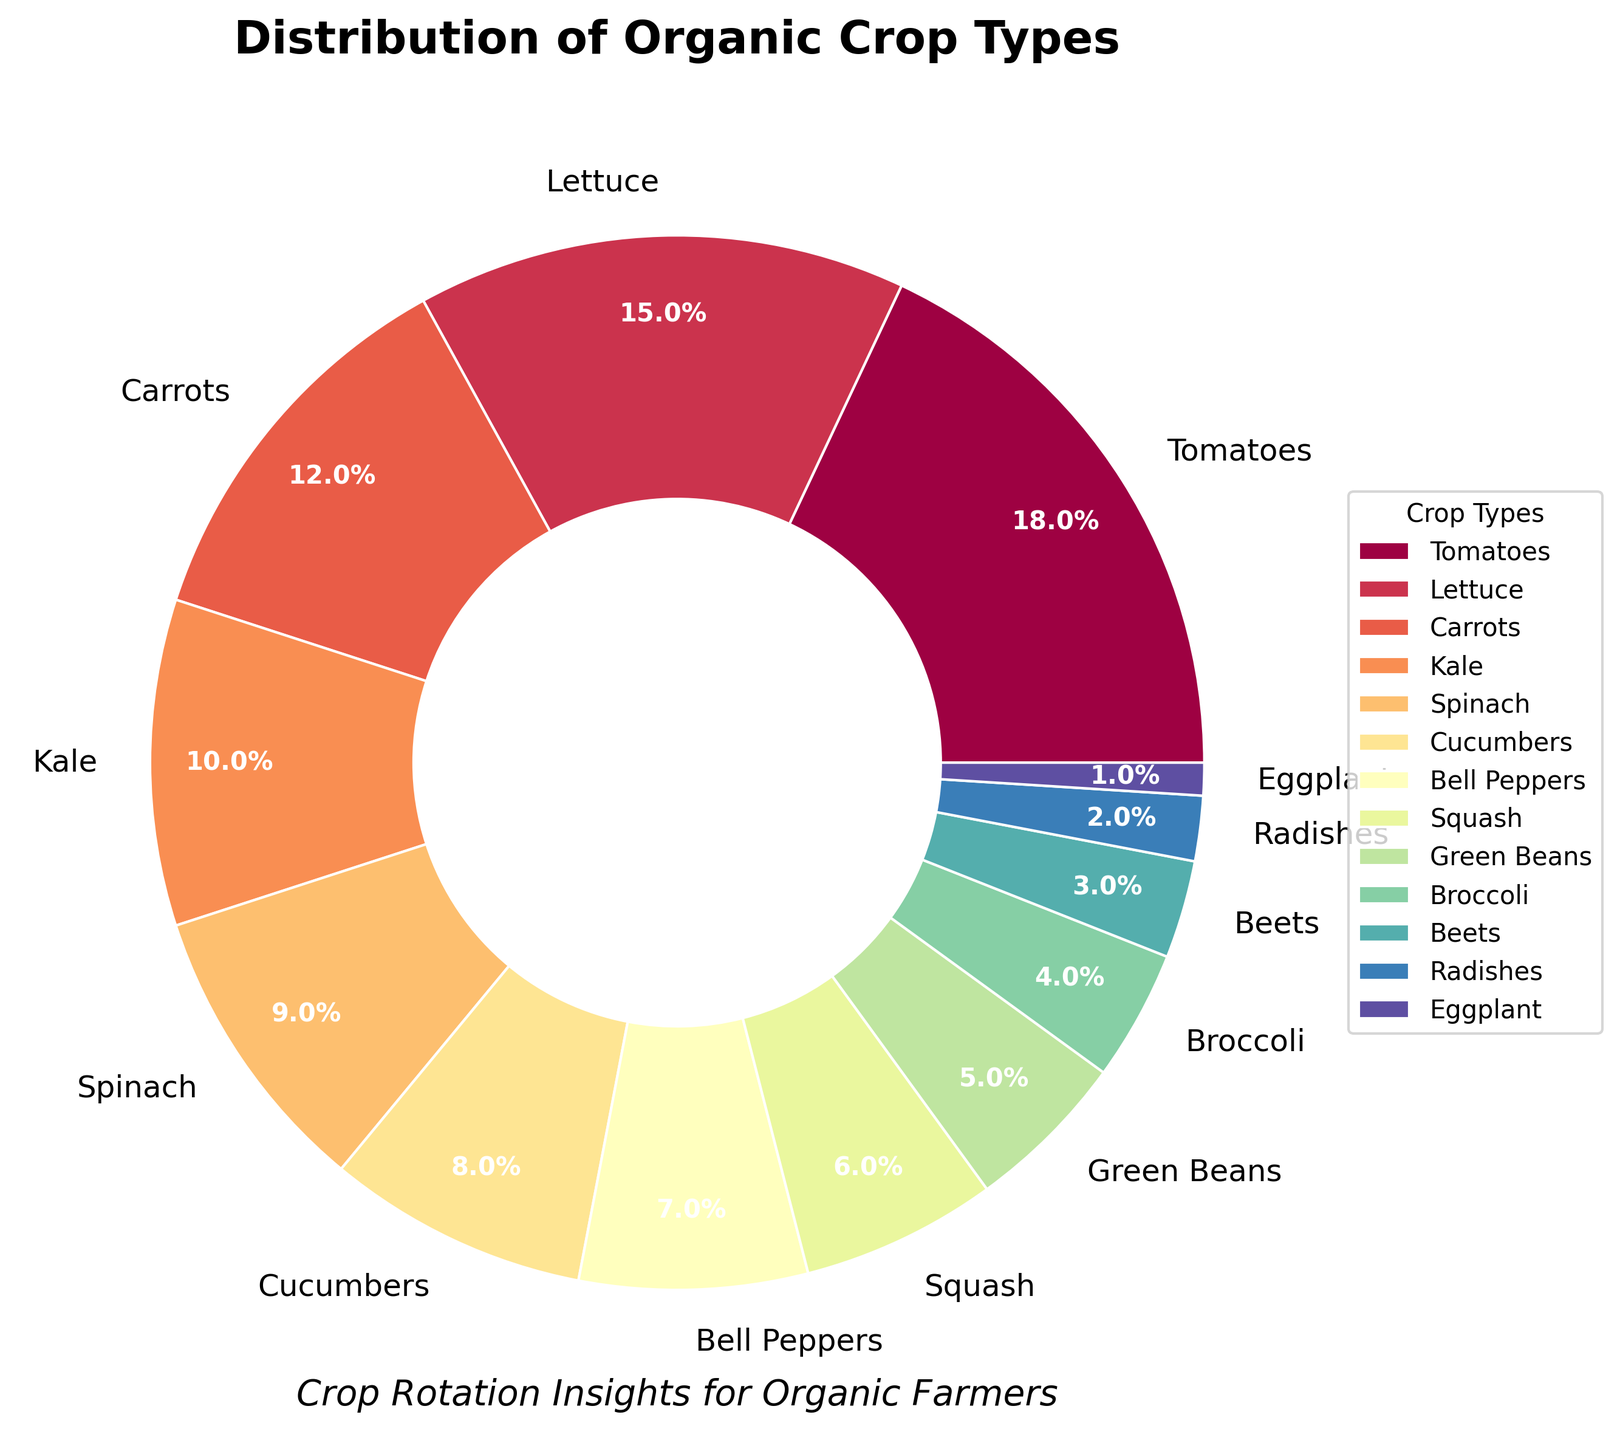What is the most grown crop according to the pie chart? The segment with the largest percentage represents the most grown crop. Tomatoes have the largest segment at 18%.
Answer: Tomatoes Which crop has the smallest percentage of growth? The segment with the smallest percentage represents the least grown crop. Eggplant has the smallest segment at 1%.
Answer: Eggplant What is the combined percentage of Lettuce, Carrots, and Kale grown in the region? Add the percentages of Lettuce, Carrots, and Kale. Lettuce (15%) + Carrots (12%) + Kale (10%) = 37%.
Answer: 37% How does the percentage of Spinach compare to that of Cucumbers? Find the percentages of both crops and compare them. Spinach is 9% and Cucumbers are 8%. Spinach has a 1% higher percentage than Cucumbers.
Answer: Spinach has a higher percentage by 1% List the crops that have a percentage of 5% or less. Identify the crops from the chart with percentages less than or equal to 5%. Green Beans (5%), Broccoli (4%), Beets (3%), Radishes (2%), and Eggplant (1%).
Answer: Green Beans, Broccoli, Beets, Radishes, and Eggplant What is the percentage difference between the most and least grown crops? Subtract the percentage of the least grown crop from the most grown crop. Tomatoes (18%) - Eggplant (1%) = 17%.
Answer: 17% What is the cumulative percentage of Squash and Beets grown? Add the percentages of Squash and Beets. Squash (6%) + Beets (3%) = 9%.
Answer: 9% If you combine the percentages of Bell Peppers and Cucumbers, how does it compare to Lettuce? Find the total percentage of Bell Peppers and Cucumbers, and compare with Lettuce. Bell Peppers (7%) + Cucumbers (8%) = 15%, which is the same as Lettuce (15%).
Answer: Equal Rank the top three crops in terms of percentage from highest to lowest. Identify and rank the crops based on their percentages. Tomatoes (18%), Lettuce (15%), and Carrots (12%).
Answer: Tomatoes, Lettuce, Carrots What is the average percentage for the top five crops? Calculate the average for the top five crops. (Tomatoes 18% + Lettuce 15% + Carrots 12% + Kale 10% + Spinach 9%) / 5 = 64 / 5 = 12.8%.
Answer: 12.8% 